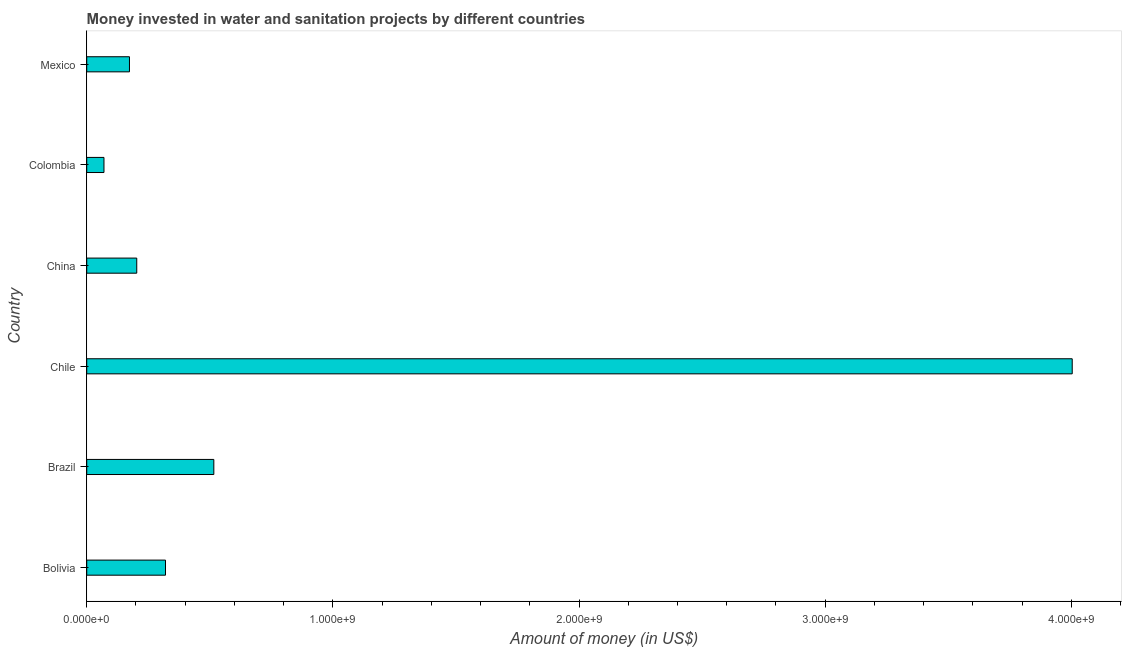What is the title of the graph?
Provide a short and direct response. Money invested in water and sanitation projects by different countries. What is the label or title of the X-axis?
Your response must be concise. Amount of money (in US$). What is the label or title of the Y-axis?
Provide a succinct answer. Country. What is the investment in Colombia?
Provide a succinct answer. 7.00e+07. Across all countries, what is the maximum investment?
Your answer should be compact. 4.00e+09. Across all countries, what is the minimum investment?
Provide a short and direct response. 7.00e+07. In which country was the investment maximum?
Offer a very short reply. Chile. What is the sum of the investment?
Provide a short and direct response. 5.29e+09. What is the difference between the investment in Chile and Mexico?
Offer a very short reply. 3.83e+09. What is the average investment per country?
Provide a succinct answer. 8.81e+08. What is the median investment?
Your answer should be compact. 2.62e+08. In how many countries, is the investment greater than 4000000000 US$?
Your response must be concise. 1. What is the ratio of the investment in Brazil to that in Colombia?
Offer a terse response. 7.38. Is the investment in Bolivia less than that in Mexico?
Make the answer very short. No. Is the difference between the investment in Bolivia and Colombia greater than the difference between any two countries?
Your response must be concise. No. What is the difference between the highest and the second highest investment?
Provide a short and direct response. 3.49e+09. What is the difference between the highest and the lowest investment?
Give a very brief answer. 3.93e+09. How many countries are there in the graph?
Provide a short and direct response. 6. Are the values on the major ticks of X-axis written in scientific E-notation?
Provide a short and direct response. Yes. What is the Amount of money (in US$) in Bolivia?
Your response must be concise. 3.20e+08. What is the Amount of money (in US$) in Brazil?
Offer a very short reply. 5.16e+08. What is the Amount of money (in US$) in Chile?
Make the answer very short. 4.00e+09. What is the Amount of money (in US$) of China?
Keep it short and to the point. 2.03e+08. What is the Amount of money (in US$) in Colombia?
Your answer should be very brief. 7.00e+07. What is the Amount of money (in US$) of Mexico?
Ensure brevity in your answer.  1.74e+08. What is the difference between the Amount of money (in US$) in Bolivia and Brazil?
Provide a short and direct response. -1.96e+08. What is the difference between the Amount of money (in US$) in Bolivia and Chile?
Your answer should be compact. -3.68e+09. What is the difference between the Amount of money (in US$) in Bolivia and China?
Make the answer very short. 1.17e+08. What is the difference between the Amount of money (in US$) in Bolivia and Colombia?
Offer a terse response. 2.50e+08. What is the difference between the Amount of money (in US$) in Bolivia and Mexico?
Make the answer very short. 1.46e+08. What is the difference between the Amount of money (in US$) in Brazil and Chile?
Provide a short and direct response. -3.49e+09. What is the difference between the Amount of money (in US$) in Brazil and China?
Your answer should be compact. 3.13e+08. What is the difference between the Amount of money (in US$) in Brazil and Colombia?
Offer a terse response. 4.46e+08. What is the difference between the Amount of money (in US$) in Brazil and Mexico?
Your response must be concise. 3.43e+08. What is the difference between the Amount of money (in US$) in Chile and China?
Your answer should be very brief. 3.80e+09. What is the difference between the Amount of money (in US$) in Chile and Colombia?
Your response must be concise. 3.93e+09. What is the difference between the Amount of money (in US$) in Chile and Mexico?
Provide a short and direct response. 3.83e+09. What is the difference between the Amount of money (in US$) in China and Colombia?
Give a very brief answer. 1.33e+08. What is the difference between the Amount of money (in US$) in China and Mexico?
Make the answer very short. 2.96e+07. What is the difference between the Amount of money (in US$) in Colombia and Mexico?
Provide a succinct answer. -1.04e+08. What is the ratio of the Amount of money (in US$) in Bolivia to that in Brazil?
Make the answer very short. 0.62. What is the ratio of the Amount of money (in US$) in Bolivia to that in Chile?
Your answer should be compact. 0.08. What is the ratio of the Amount of money (in US$) in Bolivia to that in China?
Your answer should be compact. 1.57. What is the ratio of the Amount of money (in US$) in Bolivia to that in Colombia?
Your response must be concise. 4.57. What is the ratio of the Amount of money (in US$) in Bolivia to that in Mexico?
Make the answer very short. 1.84. What is the ratio of the Amount of money (in US$) in Brazil to that in Chile?
Make the answer very short. 0.13. What is the ratio of the Amount of money (in US$) in Brazil to that in China?
Provide a short and direct response. 2.54. What is the ratio of the Amount of money (in US$) in Brazil to that in Colombia?
Your answer should be compact. 7.38. What is the ratio of the Amount of money (in US$) in Brazil to that in Mexico?
Provide a succinct answer. 2.97. What is the ratio of the Amount of money (in US$) in Chile to that in China?
Provide a succinct answer. 19.7. What is the ratio of the Amount of money (in US$) in Chile to that in Colombia?
Your answer should be compact. 57.19. What is the ratio of the Amount of money (in US$) in Chile to that in Mexico?
Your answer should be very brief. 23.06. What is the ratio of the Amount of money (in US$) in China to that in Colombia?
Your answer should be compact. 2.9. What is the ratio of the Amount of money (in US$) in China to that in Mexico?
Ensure brevity in your answer.  1.17. What is the ratio of the Amount of money (in US$) in Colombia to that in Mexico?
Offer a very short reply. 0.4. 